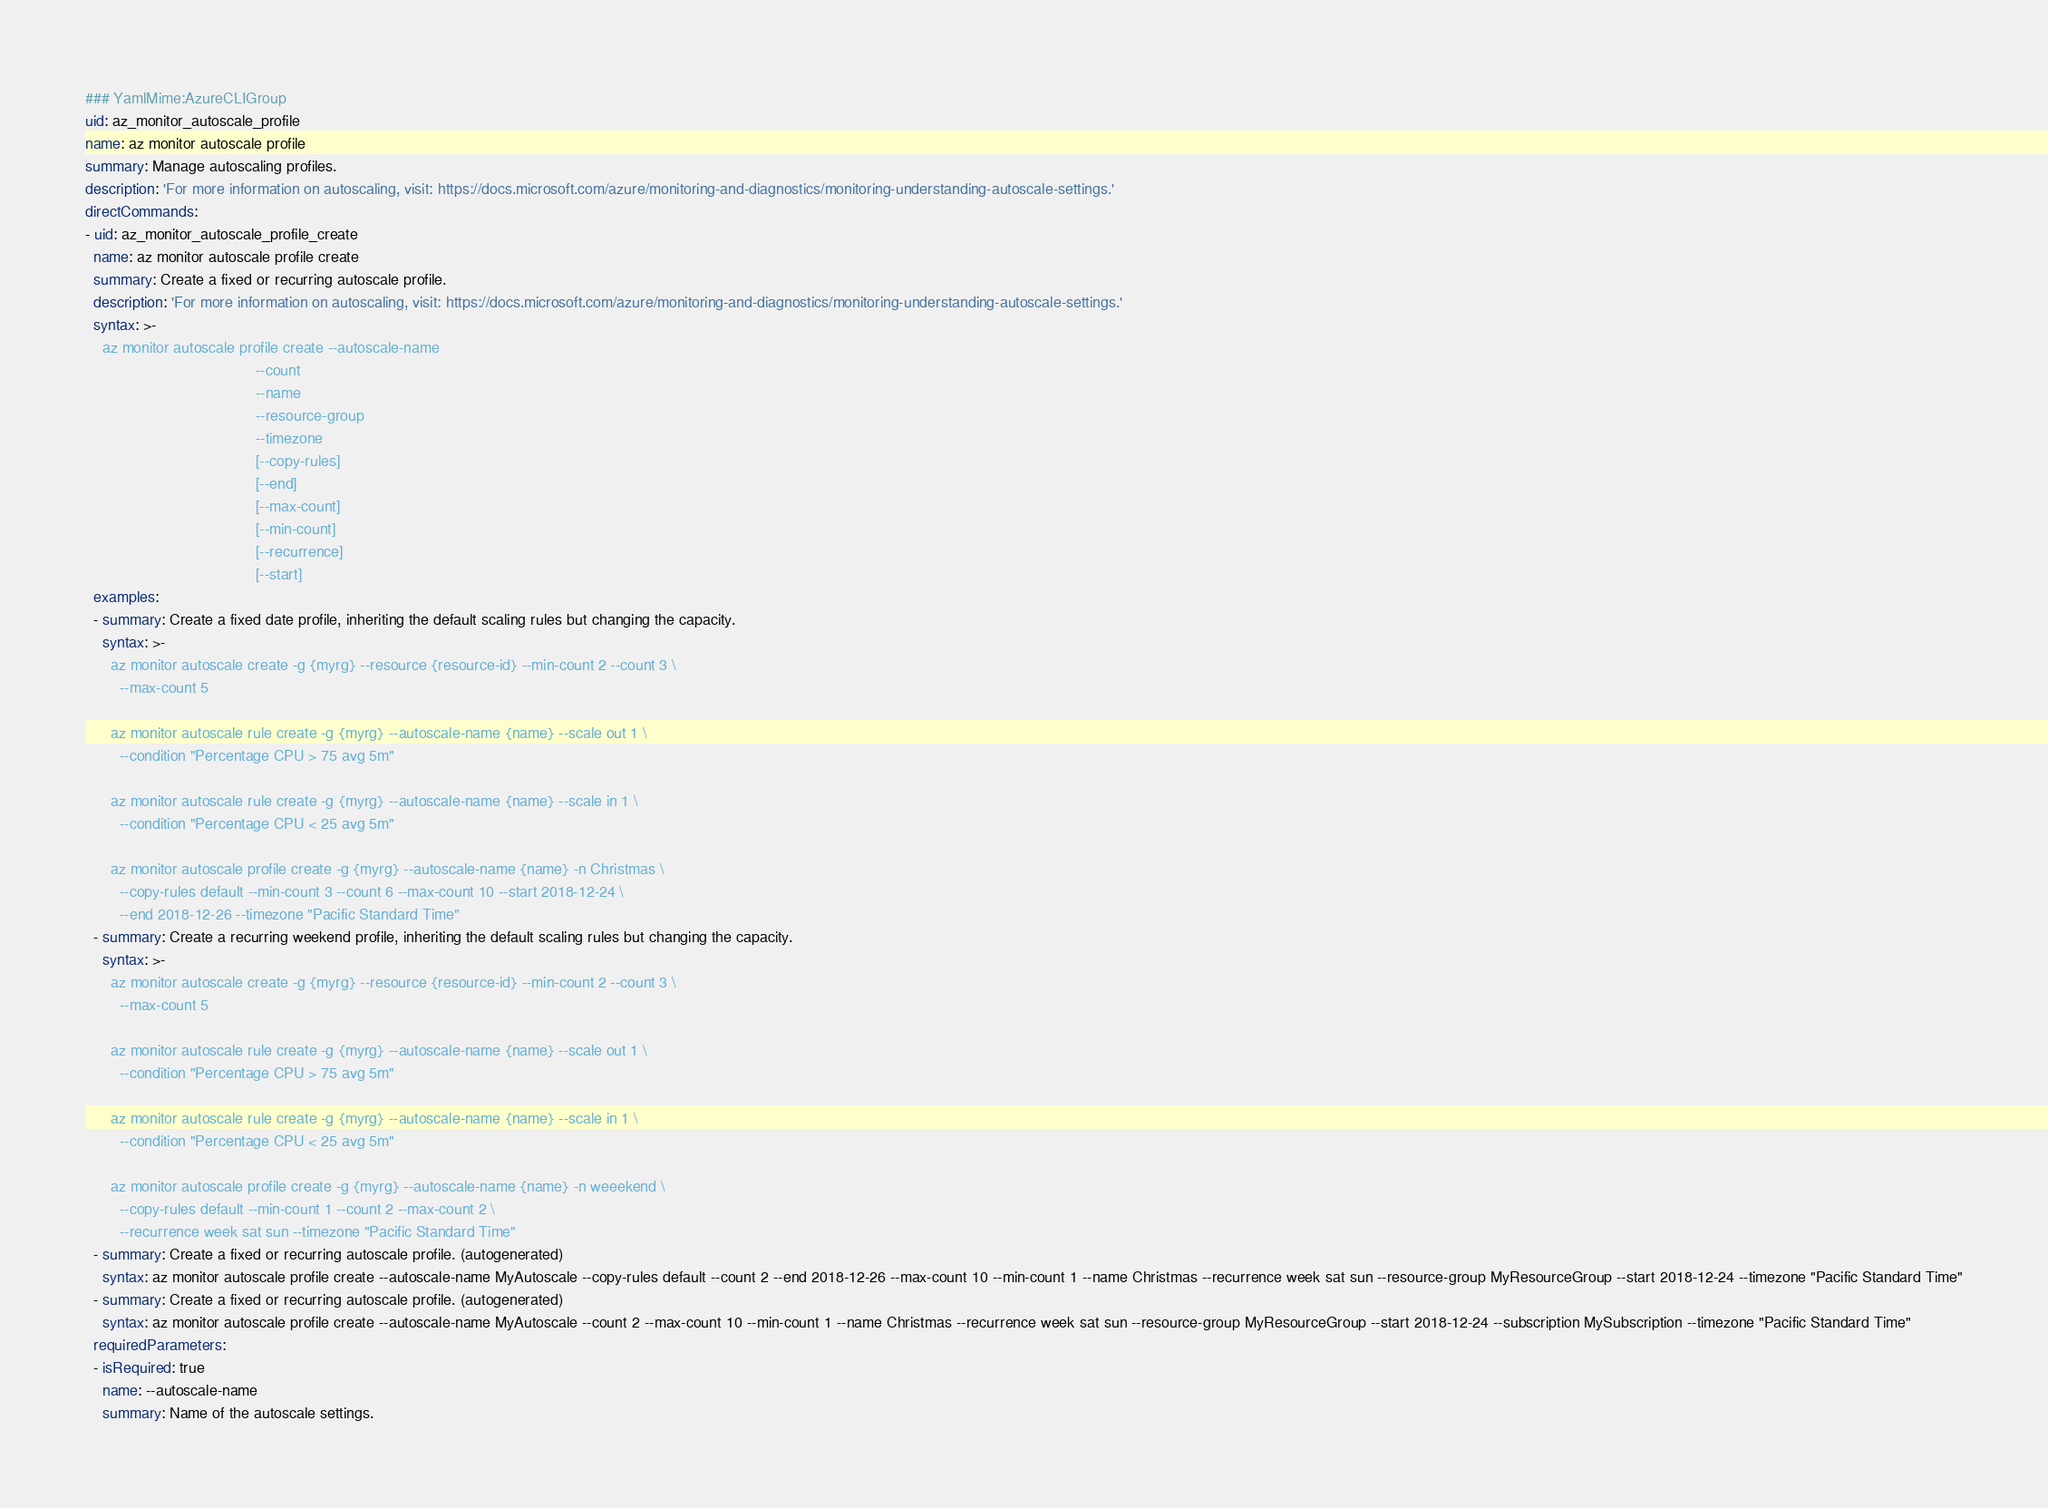<code> <loc_0><loc_0><loc_500><loc_500><_YAML_>### YamlMime:AzureCLIGroup
uid: az_monitor_autoscale_profile
name: az monitor autoscale profile
summary: Manage autoscaling profiles.
description: 'For more information on autoscaling, visit: https://docs.microsoft.com/azure/monitoring-and-diagnostics/monitoring-understanding-autoscale-settings.'
directCommands:
- uid: az_monitor_autoscale_profile_create
  name: az monitor autoscale profile create
  summary: Create a fixed or recurring autoscale profile.
  description: 'For more information on autoscaling, visit: https://docs.microsoft.com/azure/monitoring-and-diagnostics/monitoring-understanding-autoscale-settings.'
  syntax: >-
    az monitor autoscale profile create --autoscale-name
                                        --count
                                        --name
                                        --resource-group
                                        --timezone
                                        [--copy-rules]
                                        [--end]
                                        [--max-count]
                                        [--min-count]
                                        [--recurrence]
                                        [--start]
  examples:
  - summary: Create a fixed date profile, inheriting the default scaling rules but changing the capacity.
    syntax: >-
      az monitor autoscale create -g {myrg} --resource {resource-id} --min-count 2 --count 3 \
        --max-count 5

      az monitor autoscale rule create -g {myrg} --autoscale-name {name} --scale out 1 \
        --condition "Percentage CPU > 75 avg 5m"

      az monitor autoscale rule create -g {myrg} --autoscale-name {name} --scale in 1 \
        --condition "Percentage CPU < 25 avg 5m"

      az monitor autoscale profile create -g {myrg} --autoscale-name {name} -n Christmas \
        --copy-rules default --min-count 3 --count 6 --max-count 10 --start 2018-12-24 \
        --end 2018-12-26 --timezone "Pacific Standard Time"
  - summary: Create a recurring weekend profile, inheriting the default scaling rules but changing the capacity.
    syntax: >-
      az monitor autoscale create -g {myrg} --resource {resource-id} --min-count 2 --count 3 \
        --max-count 5

      az monitor autoscale rule create -g {myrg} --autoscale-name {name} --scale out 1 \
        --condition "Percentage CPU > 75 avg 5m"

      az monitor autoscale rule create -g {myrg} --autoscale-name {name} --scale in 1 \
        --condition "Percentage CPU < 25 avg 5m"

      az monitor autoscale profile create -g {myrg} --autoscale-name {name} -n weeekend \
        --copy-rules default --min-count 1 --count 2 --max-count 2 \
        --recurrence week sat sun --timezone "Pacific Standard Time"
  - summary: Create a fixed or recurring autoscale profile. (autogenerated)
    syntax: az monitor autoscale profile create --autoscale-name MyAutoscale --copy-rules default --count 2 --end 2018-12-26 --max-count 10 --min-count 1 --name Christmas --recurrence week sat sun --resource-group MyResourceGroup --start 2018-12-24 --timezone "Pacific Standard Time"
  - summary: Create a fixed or recurring autoscale profile. (autogenerated)
    syntax: az monitor autoscale profile create --autoscale-name MyAutoscale --count 2 --max-count 10 --min-count 1 --name Christmas --recurrence week sat sun --resource-group MyResourceGroup --start 2018-12-24 --subscription MySubscription --timezone "Pacific Standard Time"
  requiredParameters:
  - isRequired: true
    name: --autoscale-name
    summary: Name of the autoscale settings.</code> 